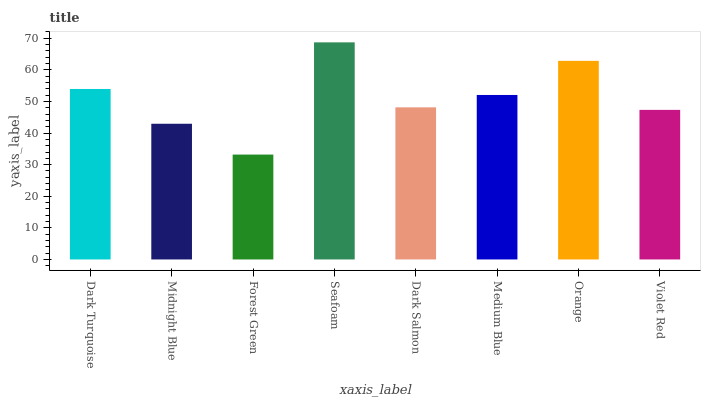Is Midnight Blue the minimum?
Answer yes or no. No. Is Midnight Blue the maximum?
Answer yes or no. No. Is Dark Turquoise greater than Midnight Blue?
Answer yes or no. Yes. Is Midnight Blue less than Dark Turquoise?
Answer yes or no. Yes. Is Midnight Blue greater than Dark Turquoise?
Answer yes or no. No. Is Dark Turquoise less than Midnight Blue?
Answer yes or no. No. Is Medium Blue the high median?
Answer yes or no. Yes. Is Dark Salmon the low median?
Answer yes or no. Yes. Is Forest Green the high median?
Answer yes or no. No. Is Midnight Blue the low median?
Answer yes or no. No. 